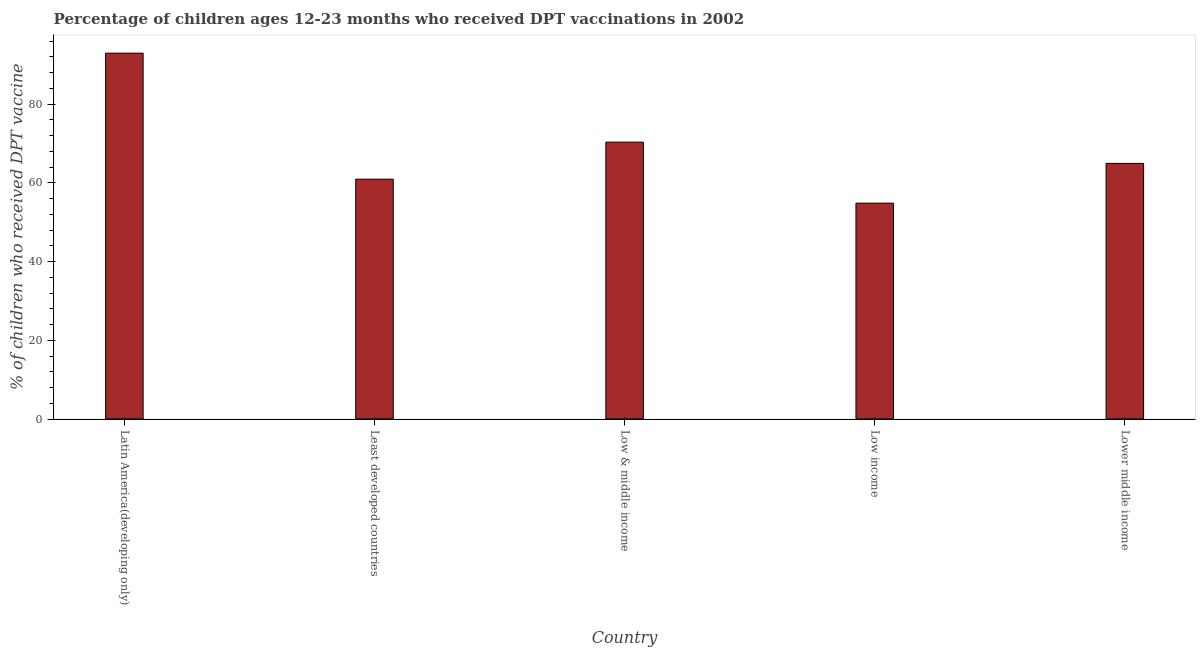Does the graph contain any zero values?
Offer a very short reply. No. What is the title of the graph?
Ensure brevity in your answer.  Percentage of children ages 12-23 months who received DPT vaccinations in 2002. What is the label or title of the X-axis?
Provide a short and direct response. Country. What is the label or title of the Y-axis?
Your response must be concise. % of children who received DPT vaccine. What is the percentage of children who received dpt vaccine in Least developed countries?
Offer a terse response. 60.93. Across all countries, what is the maximum percentage of children who received dpt vaccine?
Offer a very short reply. 92.95. Across all countries, what is the minimum percentage of children who received dpt vaccine?
Your answer should be very brief. 54.84. In which country was the percentage of children who received dpt vaccine maximum?
Provide a short and direct response. Latin America(developing only). In which country was the percentage of children who received dpt vaccine minimum?
Your answer should be compact. Low income. What is the sum of the percentage of children who received dpt vaccine?
Offer a very short reply. 344. What is the difference between the percentage of children who received dpt vaccine in Low income and Lower middle income?
Ensure brevity in your answer.  -10.1. What is the average percentage of children who received dpt vaccine per country?
Give a very brief answer. 68.8. What is the median percentage of children who received dpt vaccine?
Offer a very short reply. 64.94. What is the ratio of the percentage of children who received dpt vaccine in Low & middle income to that in Lower middle income?
Offer a terse response. 1.08. Is the percentage of children who received dpt vaccine in Low & middle income less than that in Lower middle income?
Make the answer very short. No. Is the difference between the percentage of children who received dpt vaccine in Low & middle income and Lower middle income greater than the difference between any two countries?
Ensure brevity in your answer.  No. What is the difference between the highest and the second highest percentage of children who received dpt vaccine?
Your answer should be very brief. 22.61. What is the difference between the highest and the lowest percentage of children who received dpt vaccine?
Your answer should be very brief. 38.1. How many bars are there?
Ensure brevity in your answer.  5. Are all the bars in the graph horizontal?
Give a very brief answer. No. How many countries are there in the graph?
Your answer should be compact. 5. What is the % of children who received DPT vaccine in Latin America(developing only)?
Offer a very short reply. 92.95. What is the % of children who received DPT vaccine of Least developed countries?
Offer a terse response. 60.93. What is the % of children who received DPT vaccine in Low & middle income?
Your answer should be very brief. 70.34. What is the % of children who received DPT vaccine of Low income?
Your response must be concise. 54.84. What is the % of children who received DPT vaccine in Lower middle income?
Offer a terse response. 64.94. What is the difference between the % of children who received DPT vaccine in Latin America(developing only) and Least developed countries?
Your answer should be very brief. 32.02. What is the difference between the % of children who received DPT vaccine in Latin America(developing only) and Low & middle income?
Make the answer very short. 22.61. What is the difference between the % of children who received DPT vaccine in Latin America(developing only) and Low income?
Make the answer very short. 38.1. What is the difference between the % of children who received DPT vaccine in Latin America(developing only) and Lower middle income?
Your answer should be compact. 28. What is the difference between the % of children who received DPT vaccine in Least developed countries and Low & middle income?
Offer a terse response. -9.41. What is the difference between the % of children who received DPT vaccine in Least developed countries and Low income?
Give a very brief answer. 6.09. What is the difference between the % of children who received DPT vaccine in Least developed countries and Lower middle income?
Your answer should be compact. -4.01. What is the difference between the % of children who received DPT vaccine in Low & middle income and Low income?
Your answer should be compact. 15.5. What is the difference between the % of children who received DPT vaccine in Low & middle income and Lower middle income?
Make the answer very short. 5.4. What is the difference between the % of children who received DPT vaccine in Low income and Lower middle income?
Make the answer very short. -10.1. What is the ratio of the % of children who received DPT vaccine in Latin America(developing only) to that in Least developed countries?
Ensure brevity in your answer.  1.52. What is the ratio of the % of children who received DPT vaccine in Latin America(developing only) to that in Low & middle income?
Offer a terse response. 1.32. What is the ratio of the % of children who received DPT vaccine in Latin America(developing only) to that in Low income?
Your answer should be very brief. 1.7. What is the ratio of the % of children who received DPT vaccine in Latin America(developing only) to that in Lower middle income?
Your answer should be very brief. 1.43. What is the ratio of the % of children who received DPT vaccine in Least developed countries to that in Low & middle income?
Provide a succinct answer. 0.87. What is the ratio of the % of children who received DPT vaccine in Least developed countries to that in Low income?
Offer a very short reply. 1.11. What is the ratio of the % of children who received DPT vaccine in Least developed countries to that in Lower middle income?
Give a very brief answer. 0.94. What is the ratio of the % of children who received DPT vaccine in Low & middle income to that in Low income?
Make the answer very short. 1.28. What is the ratio of the % of children who received DPT vaccine in Low & middle income to that in Lower middle income?
Offer a very short reply. 1.08. What is the ratio of the % of children who received DPT vaccine in Low income to that in Lower middle income?
Offer a very short reply. 0.84. 